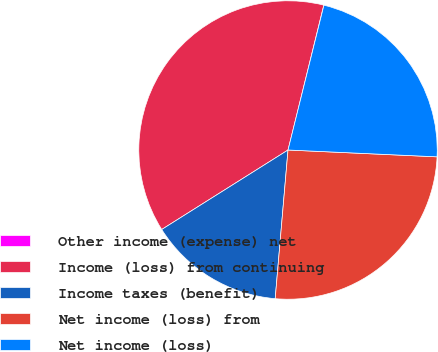<chart> <loc_0><loc_0><loc_500><loc_500><pie_chart><fcel>Other income (expense) net<fcel>Income (loss) from continuing<fcel>Income taxes (benefit)<fcel>Net income (loss) from<fcel>Net income (loss)<nl><fcel>0.02%<fcel>37.79%<fcel>14.69%<fcel>25.64%<fcel>21.86%<nl></chart> 